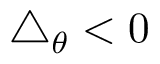<formula> <loc_0><loc_0><loc_500><loc_500>\triangle _ { \theta } < 0</formula> 